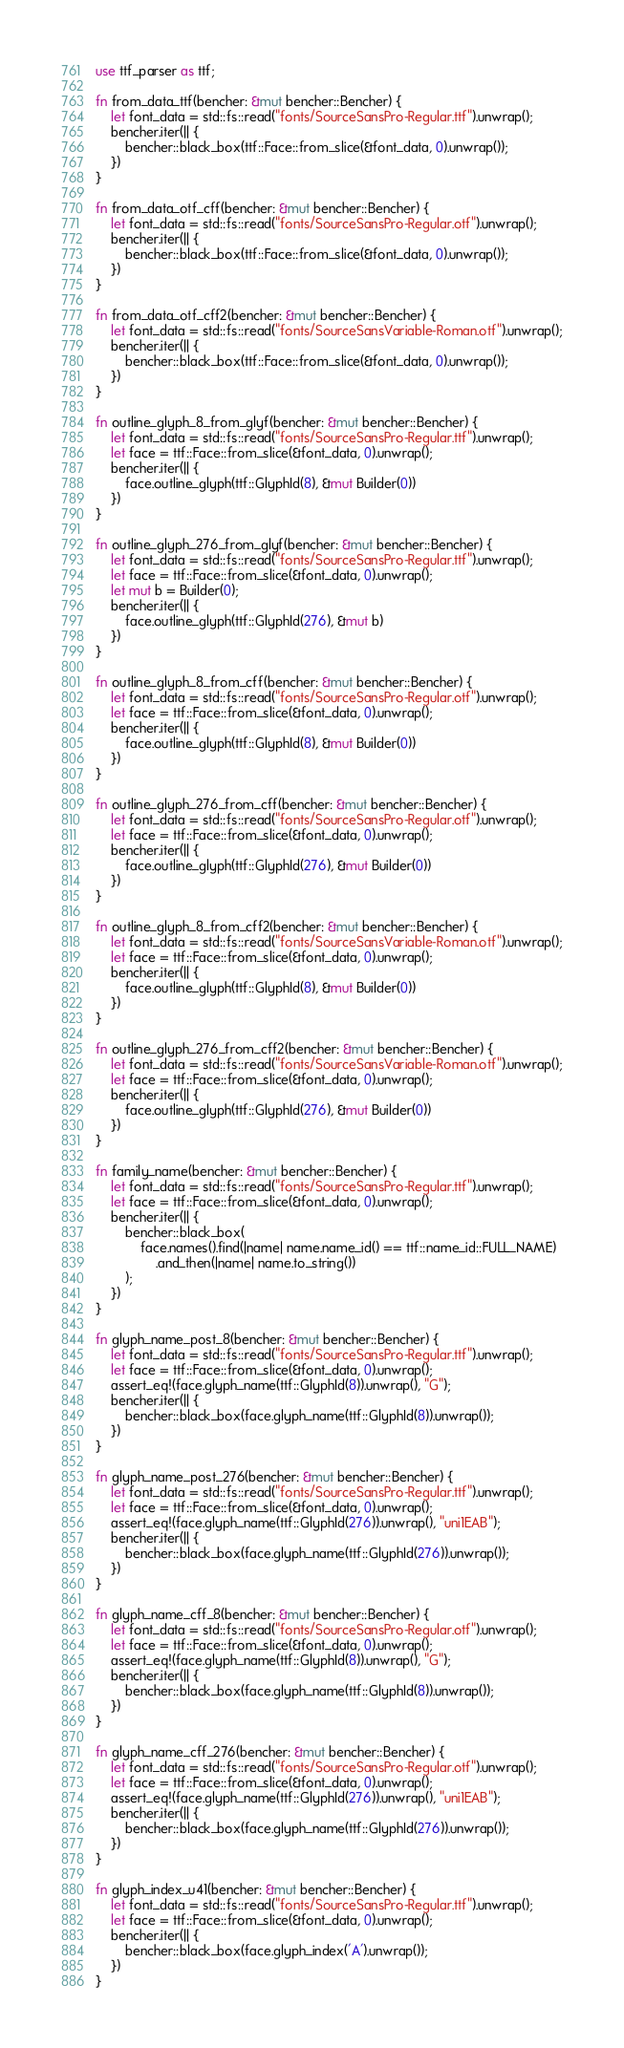Convert code to text. <code><loc_0><loc_0><loc_500><loc_500><_Rust_>use ttf_parser as ttf;

fn from_data_ttf(bencher: &mut bencher::Bencher) {
    let font_data = std::fs::read("fonts/SourceSansPro-Regular.ttf").unwrap();
    bencher.iter(|| {
        bencher::black_box(ttf::Face::from_slice(&font_data, 0).unwrap());
    })
}

fn from_data_otf_cff(bencher: &mut bencher::Bencher) {
    let font_data = std::fs::read("fonts/SourceSansPro-Regular.otf").unwrap();
    bencher.iter(|| {
        bencher::black_box(ttf::Face::from_slice(&font_data, 0).unwrap());
    })
}

fn from_data_otf_cff2(bencher: &mut bencher::Bencher) {
    let font_data = std::fs::read("fonts/SourceSansVariable-Roman.otf").unwrap();
    bencher.iter(|| {
        bencher::black_box(ttf::Face::from_slice(&font_data, 0).unwrap());
    })
}

fn outline_glyph_8_from_glyf(bencher: &mut bencher::Bencher) {
    let font_data = std::fs::read("fonts/SourceSansPro-Regular.ttf").unwrap();
    let face = ttf::Face::from_slice(&font_data, 0).unwrap();
    bencher.iter(|| {
        face.outline_glyph(ttf::GlyphId(8), &mut Builder(0))
    })
}

fn outline_glyph_276_from_glyf(bencher: &mut bencher::Bencher) {
    let font_data = std::fs::read("fonts/SourceSansPro-Regular.ttf").unwrap();
    let face = ttf::Face::from_slice(&font_data, 0).unwrap();
    let mut b = Builder(0);
    bencher.iter(|| {
        face.outline_glyph(ttf::GlyphId(276), &mut b)
    })
}

fn outline_glyph_8_from_cff(bencher: &mut bencher::Bencher) {
    let font_data = std::fs::read("fonts/SourceSansPro-Regular.otf").unwrap();
    let face = ttf::Face::from_slice(&font_data, 0).unwrap();
    bencher.iter(|| {
        face.outline_glyph(ttf::GlyphId(8), &mut Builder(0))
    })
}

fn outline_glyph_276_from_cff(bencher: &mut bencher::Bencher) {
    let font_data = std::fs::read("fonts/SourceSansPro-Regular.otf").unwrap();
    let face = ttf::Face::from_slice(&font_data, 0).unwrap();
    bencher.iter(|| {
        face.outline_glyph(ttf::GlyphId(276), &mut Builder(0))
    })
}

fn outline_glyph_8_from_cff2(bencher: &mut bencher::Bencher) {
    let font_data = std::fs::read("fonts/SourceSansVariable-Roman.otf").unwrap();
    let face = ttf::Face::from_slice(&font_data, 0).unwrap();
    bencher.iter(|| {
        face.outline_glyph(ttf::GlyphId(8), &mut Builder(0))
    })
}

fn outline_glyph_276_from_cff2(bencher: &mut bencher::Bencher) {
    let font_data = std::fs::read("fonts/SourceSansVariable-Roman.otf").unwrap();
    let face = ttf::Face::from_slice(&font_data, 0).unwrap();
    bencher.iter(|| {
        face.outline_glyph(ttf::GlyphId(276), &mut Builder(0))
    })
}

fn family_name(bencher: &mut bencher::Bencher) {
    let font_data = std::fs::read("fonts/SourceSansPro-Regular.ttf").unwrap();
    let face = ttf::Face::from_slice(&font_data, 0).unwrap();
    bencher.iter(|| {
        bencher::black_box(
            face.names().find(|name| name.name_id() == ttf::name_id::FULL_NAME)
                .and_then(|name| name.to_string())
        );
    })
}

fn glyph_name_post_8(bencher: &mut bencher::Bencher) {
    let font_data = std::fs::read("fonts/SourceSansPro-Regular.ttf").unwrap();
    let face = ttf::Face::from_slice(&font_data, 0).unwrap();
    assert_eq!(face.glyph_name(ttf::GlyphId(8)).unwrap(), "G");
    bencher.iter(|| {
        bencher::black_box(face.glyph_name(ttf::GlyphId(8)).unwrap());
    })
}

fn glyph_name_post_276(bencher: &mut bencher::Bencher) {
    let font_data = std::fs::read("fonts/SourceSansPro-Regular.ttf").unwrap();
    let face = ttf::Face::from_slice(&font_data, 0).unwrap();
    assert_eq!(face.glyph_name(ttf::GlyphId(276)).unwrap(), "uni1EAB");
    bencher.iter(|| {
        bencher::black_box(face.glyph_name(ttf::GlyphId(276)).unwrap());
    })
}

fn glyph_name_cff_8(bencher: &mut bencher::Bencher) {
    let font_data = std::fs::read("fonts/SourceSansPro-Regular.otf").unwrap();
    let face = ttf::Face::from_slice(&font_data, 0).unwrap();
    assert_eq!(face.glyph_name(ttf::GlyphId(8)).unwrap(), "G");
    bencher.iter(|| {
        bencher::black_box(face.glyph_name(ttf::GlyphId(8)).unwrap());
    })
}

fn glyph_name_cff_276(bencher: &mut bencher::Bencher) {
    let font_data = std::fs::read("fonts/SourceSansPro-Regular.otf").unwrap();
    let face = ttf::Face::from_slice(&font_data, 0).unwrap();
    assert_eq!(face.glyph_name(ttf::GlyphId(276)).unwrap(), "uni1EAB");
    bencher.iter(|| {
        bencher::black_box(face.glyph_name(ttf::GlyphId(276)).unwrap());
    })
}

fn glyph_index_u41(bencher: &mut bencher::Bencher) {
    let font_data = std::fs::read("fonts/SourceSansPro-Regular.ttf").unwrap();
    let face = ttf::Face::from_slice(&font_data, 0).unwrap();
    bencher.iter(|| {
        bencher::black_box(face.glyph_index('A').unwrap());
    })
}
</code> 